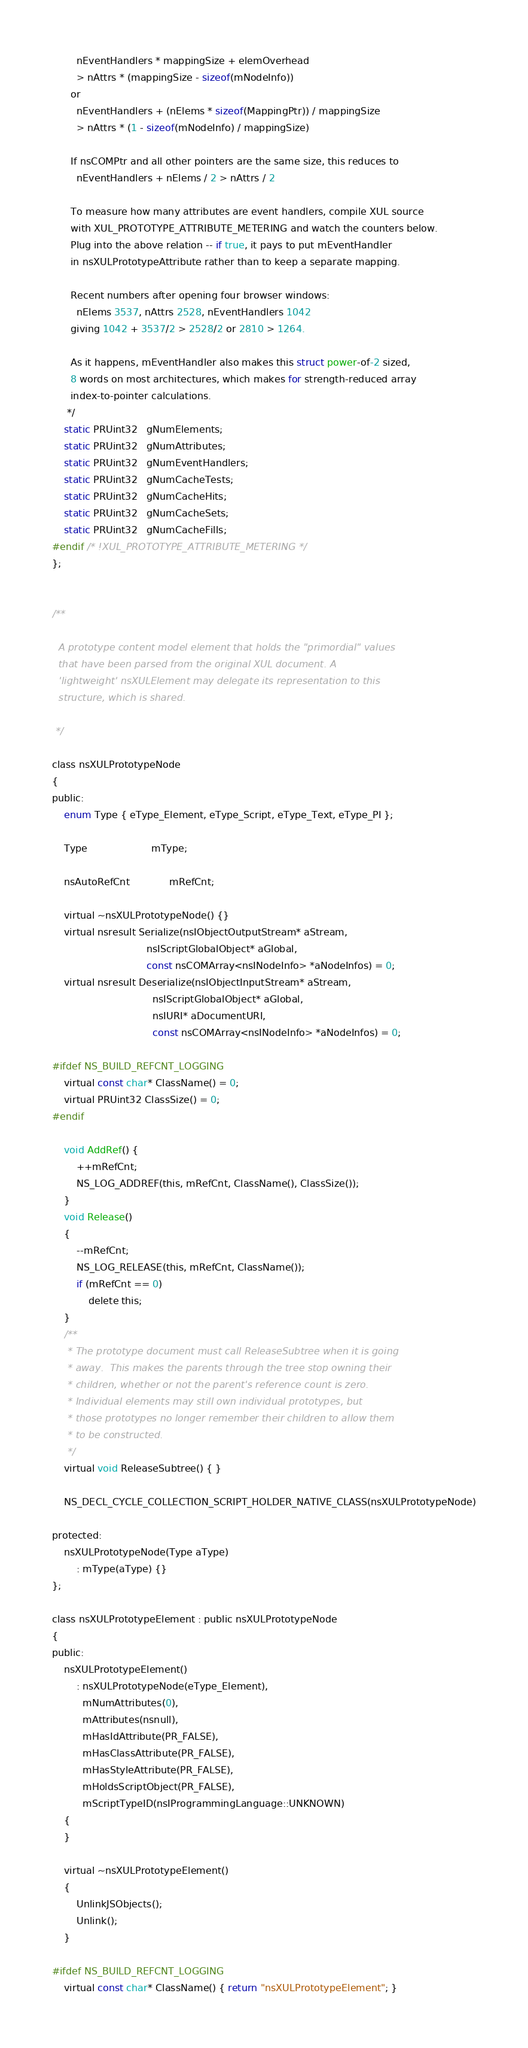Convert code to text. <code><loc_0><loc_0><loc_500><loc_500><_C_>        nEventHandlers * mappingSize + elemOverhead
        > nAttrs * (mappingSize - sizeof(mNodeInfo))
      or
        nEventHandlers + (nElems * sizeof(MappingPtr)) / mappingSize
        > nAttrs * (1 - sizeof(mNodeInfo) / mappingSize)

      If nsCOMPtr and all other pointers are the same size, this reduces to
        nEventHandlers + nElems / 2 > nAttrs / 2

      To measure how many attributes are event handlers, compile XUL source
      with XUL_PROTOTYPE_ATTRIBUTE_METERING and watch the counters below.
      Plug into the above relation -- if true, it pays to put mEventHandler
      in nsXULPrototypeAttribute rather than to keep a separate mapping.

      Recent numbers after opening four browser windows:
        nElems 3537, nAttrs 2528, nEventHandlers 1042
      giving 1042 + 3537/2 > 2528/2 or 2810 > 1264.

      As it happens, mEventHandler also makes this struct power-of-2 sized,
      8 words on most architectures, which makes for strength-reduced array
      index-to-pointer calculations.
     */
    static PRUint32   gNumElements;
    static PRUint32   gNumAttributes;
    static PRUint32   gNumEventHandlers;
    static PRUint32   gNumCacheTests;
    static PRUint32   gNumCacheHits;
    static PRUint32   gNumCacheSets;
    static PRUint32   gNumCacheFills;
#endif /* !XUL_PROTOTYPE_ATTRIBUTE_METERING */
};


/**

  A prototype content model element that holds the "primordial" values
  that have been parsed from the original XUL document. A
  'lightweight' nsXULElement may delegate its representation to this
  structure, which is shared.

 */

class nsXULPrototypeNode
{
public:
    enum Type { eType_Element, eType_Script, eType_Text, eType_PI };

    Type                     mType;

    nsAutoRefCnt             mRefCnt;

    virtual ~nsXULPrototypeNode() {}
    virtual nsresult Serialize(nsIObjectOutputStream* aStream,
                               nsIScriptGlobalObject* aGlobal,
                               const nsCOMArray<nsINodeInfo> *aNodeInfos) = 0;
    virtual nsresult Deserialize(nsIObjectInputStream* aStream,
                                 nsIScriptGlobalObject* aGlobal,
                                 nsIURI* aDocumentURI,
                                 const nsCOMArray<nsINodeInfo> *aNodeInfos) = 0;

#ifdef NS_BUILD_REFCNT_LOGGING
    virtual const char* ClassName() = 0;
    virtual PRUint32 ClassSize() = 0;
#endif

    void AddRef() {
        ++mRefCnt;
        NS_LOG_ADDREF(this, mRefCnt, ClassName(), ClassSize());
    }
    void Release()
    {
        --mRefCnt;
        NS_LOG_RELEASE(this, mRefCnt, ClassName());
        if (mRefCnt == 0)
            delete this;
    }
    /**
     * The prototype document must call ReleaseSubtree when it is going
     * away.  This makes the parents through the tree stop owning their
     * children, whether or not the parent's reference count is zero.
     * Individual elements may still own individual prototypes, but
     * those prototypes no longer remember their children to allow them
     * to be constructed.
     */
    virtual void ReleaseSubtree() { }

    NS_DECL_CYCLE_COLLECTION_SCRIPT_HOLDER_NATIVE_CLASS(nsXULPrototypeNode)

protected:
    nsXULPrototypeNode(Type aType)
        : mType(aType) {}
};

class nsXULPrototypeElement : public nsXULPrototypeNode
{
public:
    nsXULPrototypeElement()
        : nsXULPrototypeNode(eType_Element),
          mNumAttributes(0),
          mAttributes(nsnull),
          mHasIdAttribute(PR_FALSE),
          mHasClassAttribute(PR_FALSE),
          mHasStyleAttribute(PR_FALSE),
          mHoldsScriptObject(PR_FALSE),
          mScriptTypeID(nsIProgrammingLanguage::UNKNOWN)
    {
    }

    virtual ~nsXULPrototypeElement()
    {
        UnlinkJSObjects();
        Unlink();
    }

#ifdef NS_BUILD_REFCNT_LOGGING
    virtual const char* ClassName() { return "nsXULPrototypeElement"; }</code> 